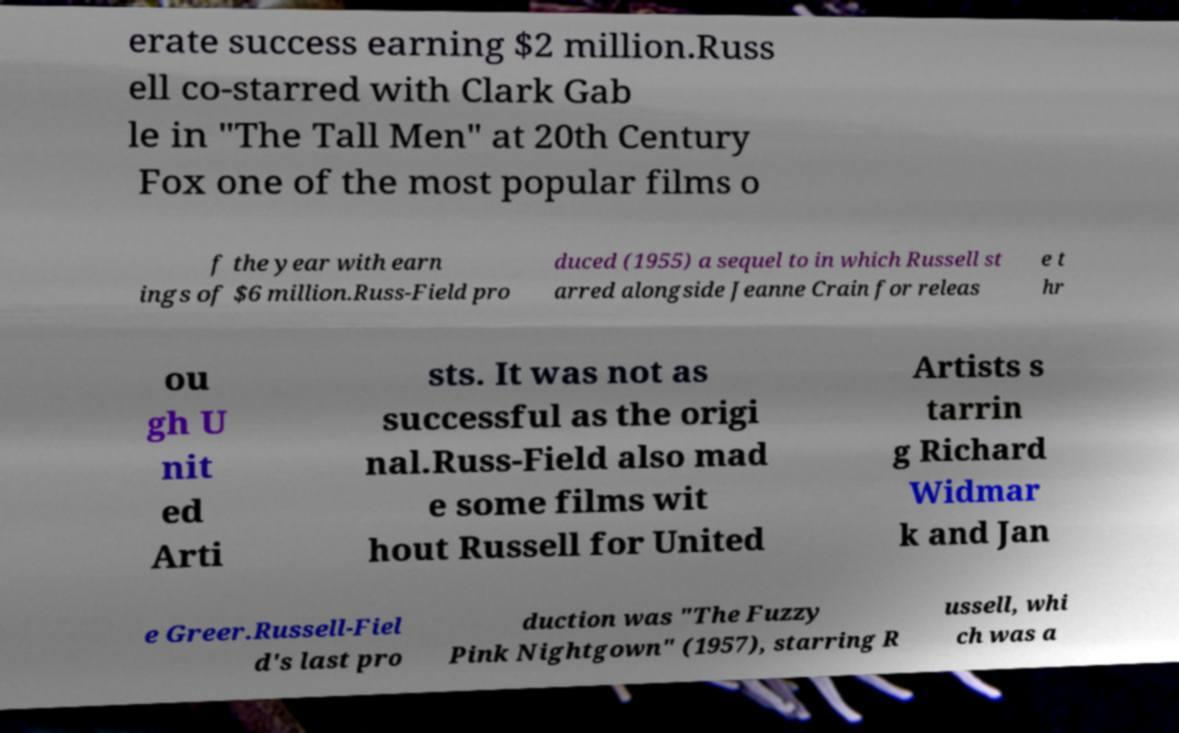Could you extract and type out the text from this image? erate success earning $2 million.Russ ell co-starred with Clark Gab le in "The Tall Men" at 20th Century Fox one of the most popular films o f the year with earn ings of $6 million.Russ-Field pro duced (1955) a sequel to in which Russell st arred alongside Jeanne Crain for releas e t hr ou gh U nit ed Arti sts. It was not as successful as the origi nal.Russ-Field also mad e some films wit hout Russell for United Artists s tarrin g Richard Widmar k and Jan e Greer.Russell-Fiel d's last pro duction was "The Fuzzy Pink Nightgown" (1957), starring R ussell, whi ch was a 